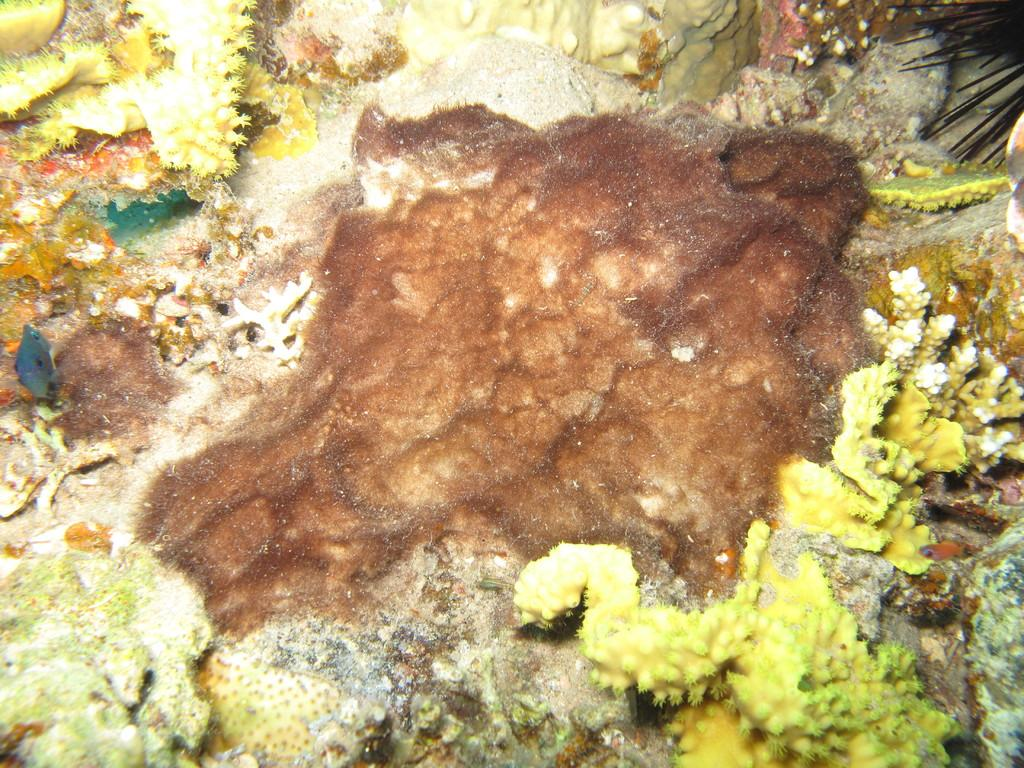What type of living organisms can be seen in the image? Plants can be seen in the image. Can you describe the brown color patch in the center of the image? There is a brown color patch in the center of the image. What type of salt can be seen sprinkled on the plants in the image? There is no salt present in the image; it features plants and a brown color patch. 